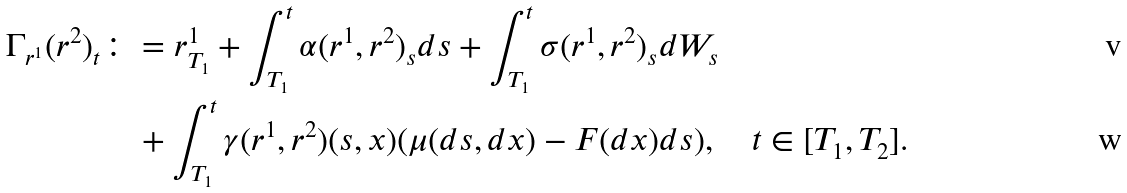<formula> <loc_0><loc_0><loc_500><loc_500>\Gamma _ { r ^ { 1 } } ( r ^ { 2 } ) _ { t } & \colon = r _ { T _ { 1 } } ^ { 1 } + \int _ { T _ { 1 } } ^ { t } \alpha ( r ^ { 1 } , r ^ { 2 } ) _ { s } d s + \int _ { T _ { 1 } } ^ { t } \sigma ( r ^ { 1 } , r ^ { 2 } ) _ { s } d W _ { s } \\ & \quad + \int _ { T _ { 1 } } ^ { t } \gamma ( r ^ { 1 } , r ^ { 2 } ) ( s , x ) ( \mu ( d s , d x ) - F ( d x ) d s ) , \quad t \in [ T _ { 1 } , T _ { 2 } ] .</formula> 